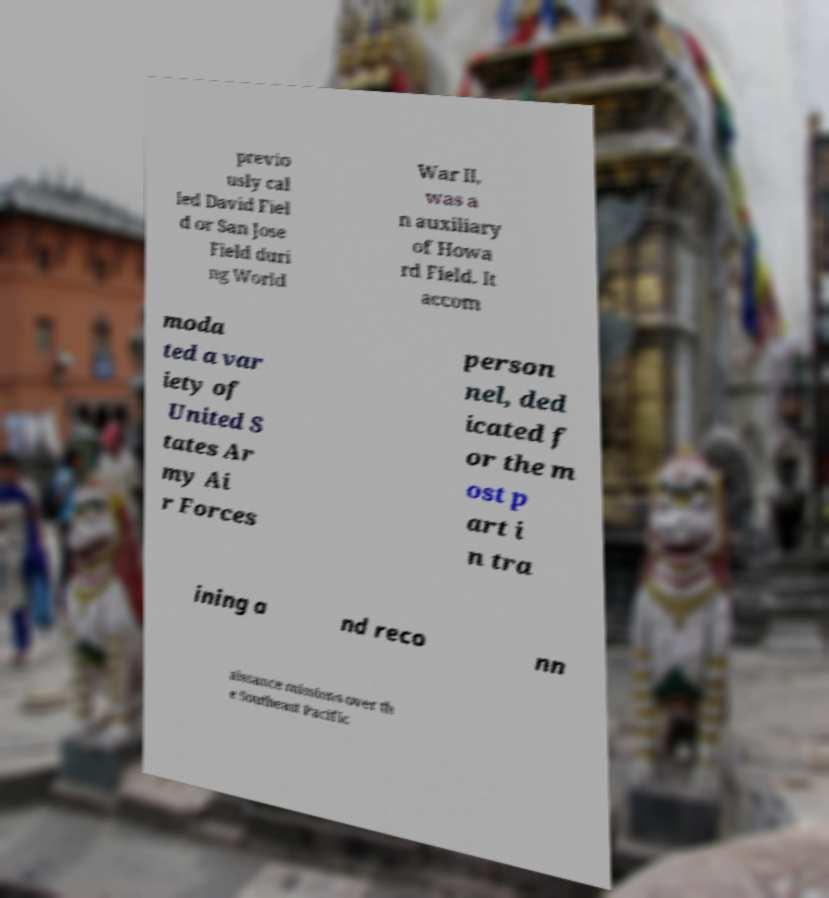What messages or text are displayed in this image? I need them in a readable, typed format. previo usly cal led David Fiel d or San Jose Field duri ng World War II, was a n auxiliary of Howa rd Field. It accom moda ted a var iety of United S tates Ar my Ai r Forces person nel, ded icated f or the m ost p art i n tra ining a nd reco nn aissance missions over th e Southeast Pacific 